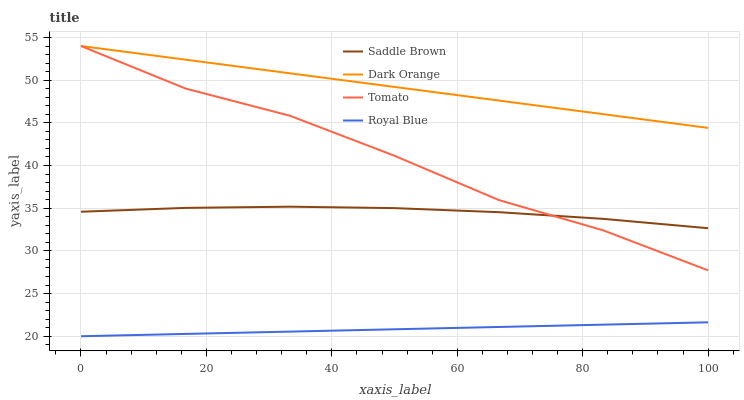Does Royal Blue have the minimum area under the curve?
Answer yes or no. Yes. Does Dark Orange have the maximum area under the curve?
Answer yes or no. Yes. Does Saddle Brown have the minimum area under the curve?
Answer yes or no. No. Does Saddle Brown have the maximum area under the curve?
Answer yes or no. No. Is Royal Blue the smoothest?
Answer yes or no. Yes. Is Tomato the roughest?
Answer yes or no. Yes. Is Dark Orange the smoothest?
Answer yes or no. No. Is Dark Orange the roughest?
Answer yes or no. No. Does Saddle Brown have the lowest value?
Answer yes or no. No. Does Dark Orange have the highest value?
Answer yes or no. Yes. Does Saddle Brown have the highest value?
Answer yes or no. No. Is Royal Blue less than Tomato?
Answer yes or no. Yes. Is Dark Orange greater than Saddle Brown?
Answer yes or no. Yes. Does Tomato intersect Dark Orange?
Answer yes or no. Yes. Is Tomato less than Dark Orange?
Answer yes or no. No. Is Tomato greater than Dark Orange?
Answer yes or no. No. Does Royal Blue intersect Tomato?
Answer yes or no. No. 